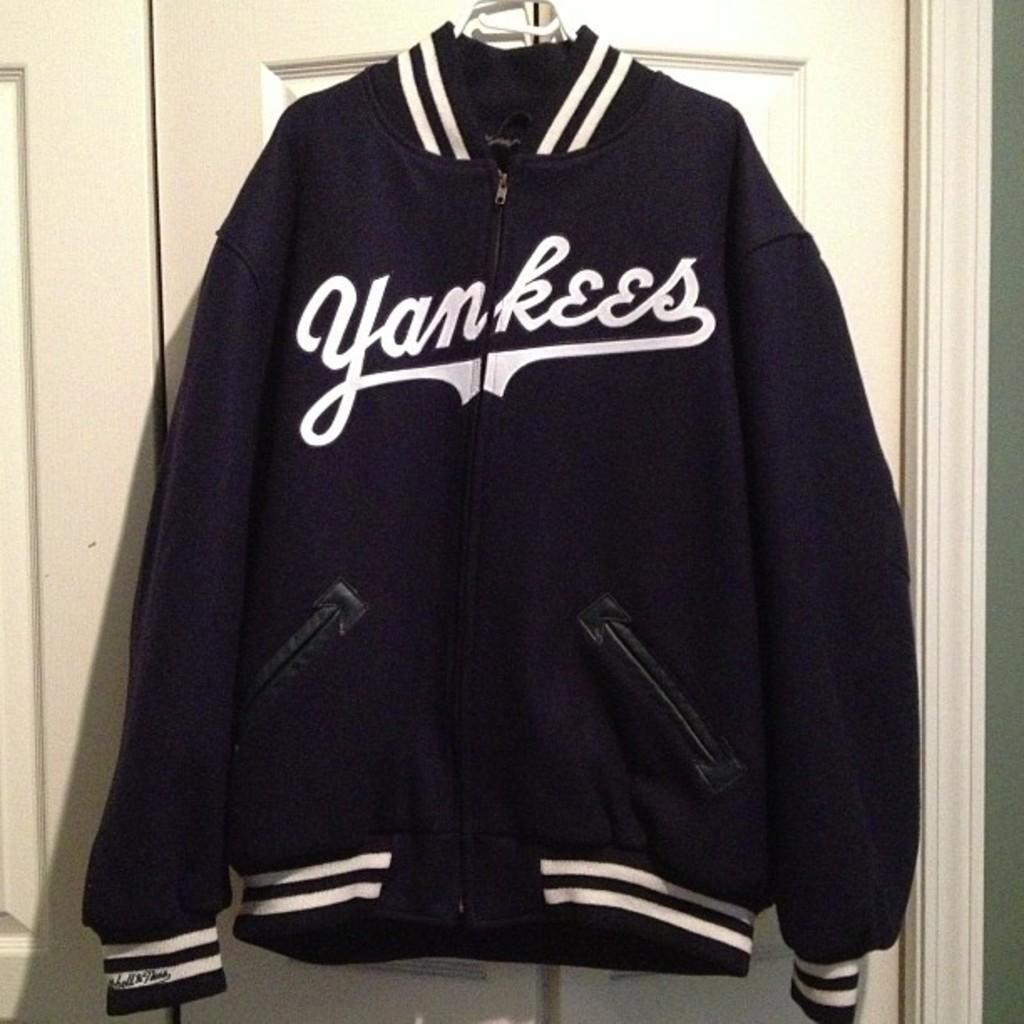Provide a one-sentence caption for the provided image. A black Yankees jacket with white strips on the sleeves and on the bottom of the jacket. 